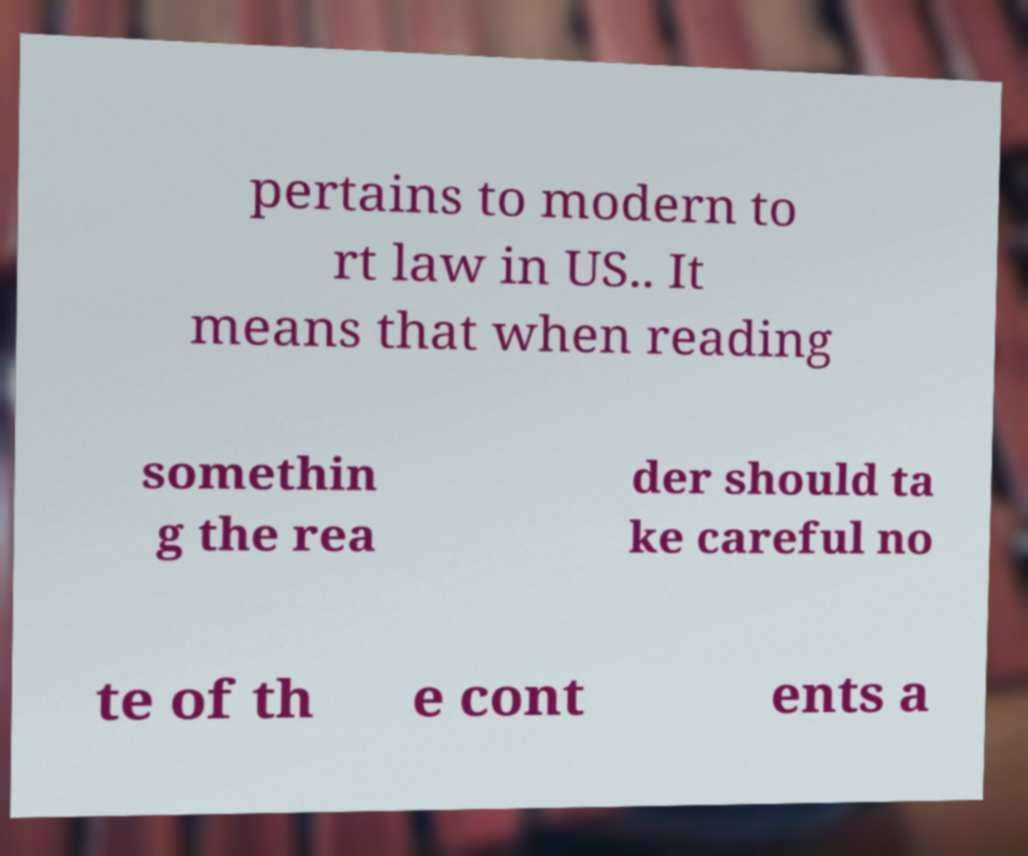Could you extract and type out the text from this image? pertains to modern to rt law in US.. It means that when reading somethin g the rea der should ta ke careful no te of th e cont ents a 